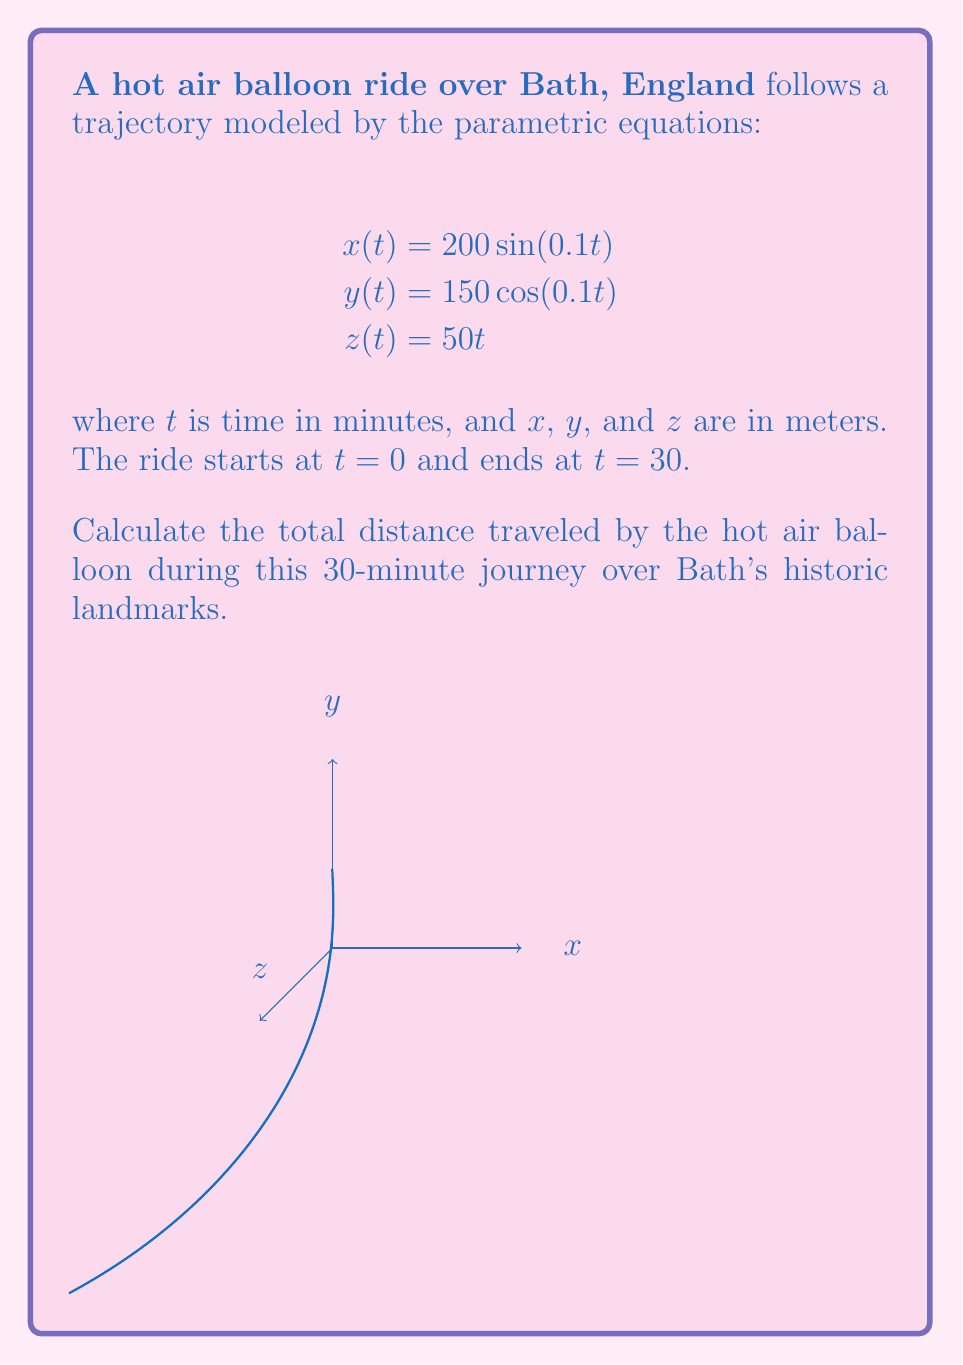Help me with this question. To find the total distance traveled, we need to calculate the arc length of the parametric curve. The formula for arc length in 3D parametric equations is:

$$L = \int_{a}^{b} \sqrt{\left(\frac{dx}{dt}\right)^2 + \left(\frac{dy}{dt}\right)^2 + \left(\frac{dz}{dt}\right)^2} dt$$

Step 1: Calculate the derivatives
$$\frac{dx}{dt} = 20\cos(0.1t)$$
$$\frac{dy}{dt} = -15\sin(0.1t)$$
$$\frac{dz}{dt} = 50$$

Step 2: Substitute into the arc length formula
$$L = \int_{0}^{30} \sqrt{(20\cos(0.1t))^2 + (-15\sin(0.1t))^2 + 50^2} dt$$

Step 3: Simplify under the square root
$$L = \int_{0}^{30} \sqrt{400\cos^2(0.1t) + 225\sin^2(0.1t) + 2500} dt$$
$$L = \int_{0}^{30} \sqrt{400(\cos^2(0.1t) + \sin^2(0.1t)) - 175\sin^2(0.1t) + 2500} dt$$
$$L = \int_{0}^{30} \sqrt{400 + 2500} dt$$ (since $\cos^2(0.1t) + \sin^2(0.1t) = 1$)
$$L = \int_{0}^{30} \sqrt{2900} dt$$

Step 4: Evaluate the integral
$$L = \sqrt{2900} \int_{0}^{30} dt = \sqrt{2900} \cdot 30 = 30\sqrt{2900} \approx 1612.45$$

Therefore, the total distance traveled is approximately 1612.45 meters.
Answer: $30\sqrt{2900} \approx 1612.45$ meters 